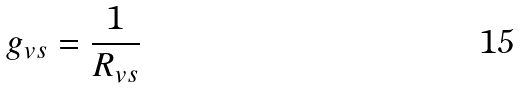Convert formula to latex. <formula><loc_0><loc_0><loc_500><loc_500>g _ { v s } = \frac { 1 } { R _ { v s } }</formula> 